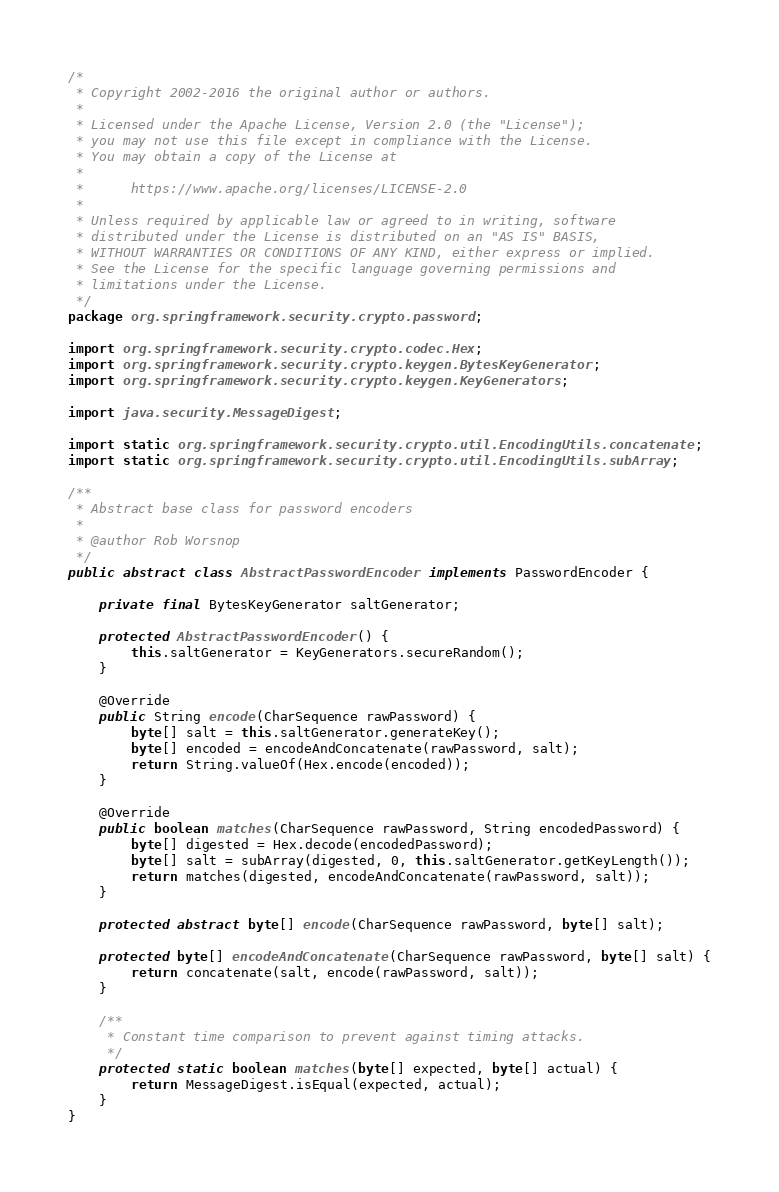<code> <loc_0><loc_0><loc_500><loc_500><_Java_>/*
 * Copyright 2002-2016 the original author or authors.
 *
 * Licensed under the Apache License, Version 2.0 (the "License");
 * you may not use this file except in compliance with the License.
 * You may obtain a copy of the License at
 *
 *      https://www.apache.org/licenses/LICENSE-2.0
 *
 * Unless required by applicable law or agreed to in writing, software
 * distributed under the License is distributed on an "AS IS" BASIS,
 * WITHOUT WARRANTIES OR CONDITIONS OF ANY KIND, either express or implied.
 * See the License for the specific language governing permissions and
 * limitations under the License.
 */
package org.springframework.security.crypto.password;

import org.springframework.security.crypto.codec.Hex;
import org.springframework.security.crypto.keygen.BytesKeyGenerator;
import org.springframework.security.crypto.keygen.KeyGenerators;

import java.security.MessageDigest;

import static org.springframework.security.crypto.util.EncodingUtils.concatenate;
import static org.springframework.security.crypto.util.EncodingUtils.subArray;

/**
 * Abstract base class for password encoders
 *
 * @author Rob Worsnop
 */
public abstract class AbstractPasswordEncoder implements PasswordEncoder {

	private final BytesKeyGenerator saltGenerator;

	protected AbstractPasswordEncoder() {
		this.saltGenerator = KeyGenerators.secureRandom();
	}

	@Override
	public String encode(CharSequence rawPassword) {
		byte[] salt = this.saltGenerator.generateKey();
		byte[] encoded = encodeAndConcatenate(rawPassword, salt);
		return String.valueOf(Hex.encode(encoded));
	}

	@Override
	public boolean matches(CharSequence rawPassword, String encodedPassword) {
		byte[] digested = Hex.decode(encodedPassword);
		byte[] salt = subArray(digested, 0, this.saltGenerator.getKeyLength());
		return matches(digested, encodeAndConcatenate(rawPassword, salt));
	}

	protected abstract byte[] encode(CharSequence rawPassword, byte[] salt);

	protected byte[] encodeAndConcatenate(CharSequence rawPassword, byte[] salt) {
		return concatenate(salt, encode(rawPassword, salt));
	}

	/**
	 * Constant time comparison to prevent against timing attacks.
	 */
	protected static boolean matches(byte[] expected, byte[] actual) {
		return MessageDigest.isEqual(expected, actual);
	}
}
</code> 